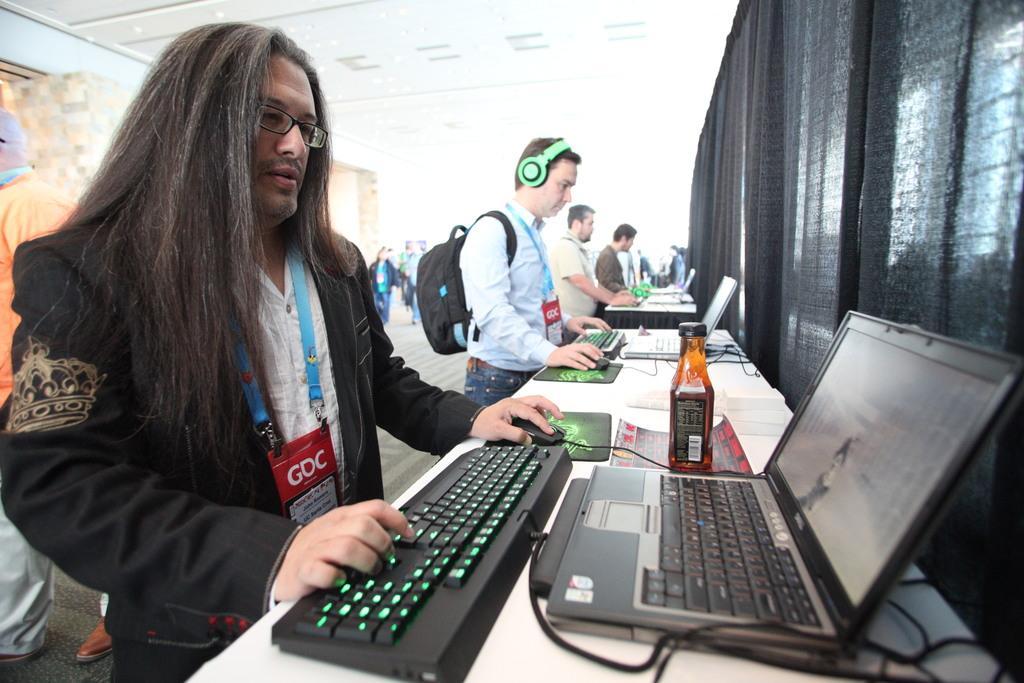Please provide a concise description of this image. In the center of the image we can see a few people are standing and they are in different costumes and they are holding some objects. Among them, we can see one person is wearing a backpack and a headset. In front of them, we can see tables. On the tables, we can see laptops, keyboards, wired, mouses, one bottle and a few other objects. Behind the table, we can see one black cloth. In the background there is a wall, roof, carpet, few people are standing and a few other objects. 